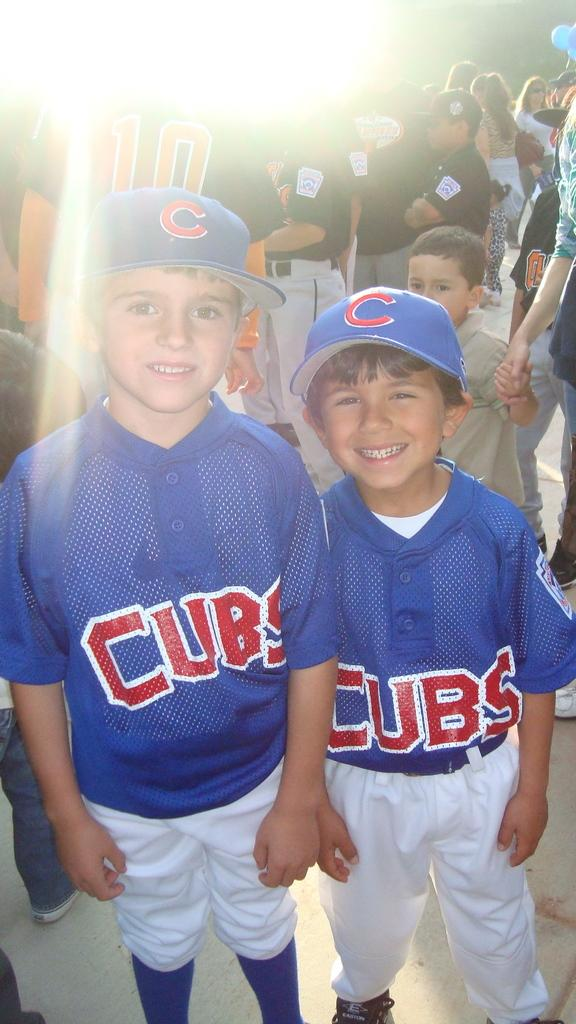<image>
Write a terse but informative summary of the picture. the two boys are wearing Cubs baseball jersey 